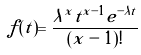<formula> <loc_0><loc_0><loc_500><loc_500>f ( t ) = \frac { \lambda ^ { x } t ^ { x - 1 } e ^ { - \lambda t } } { ( x - 1 ) ! }</formula> 